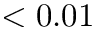Convert formula to latex. <formula><loc_0><loc_0><loc_500><loc_500>< 0 . 0 1</formula> 